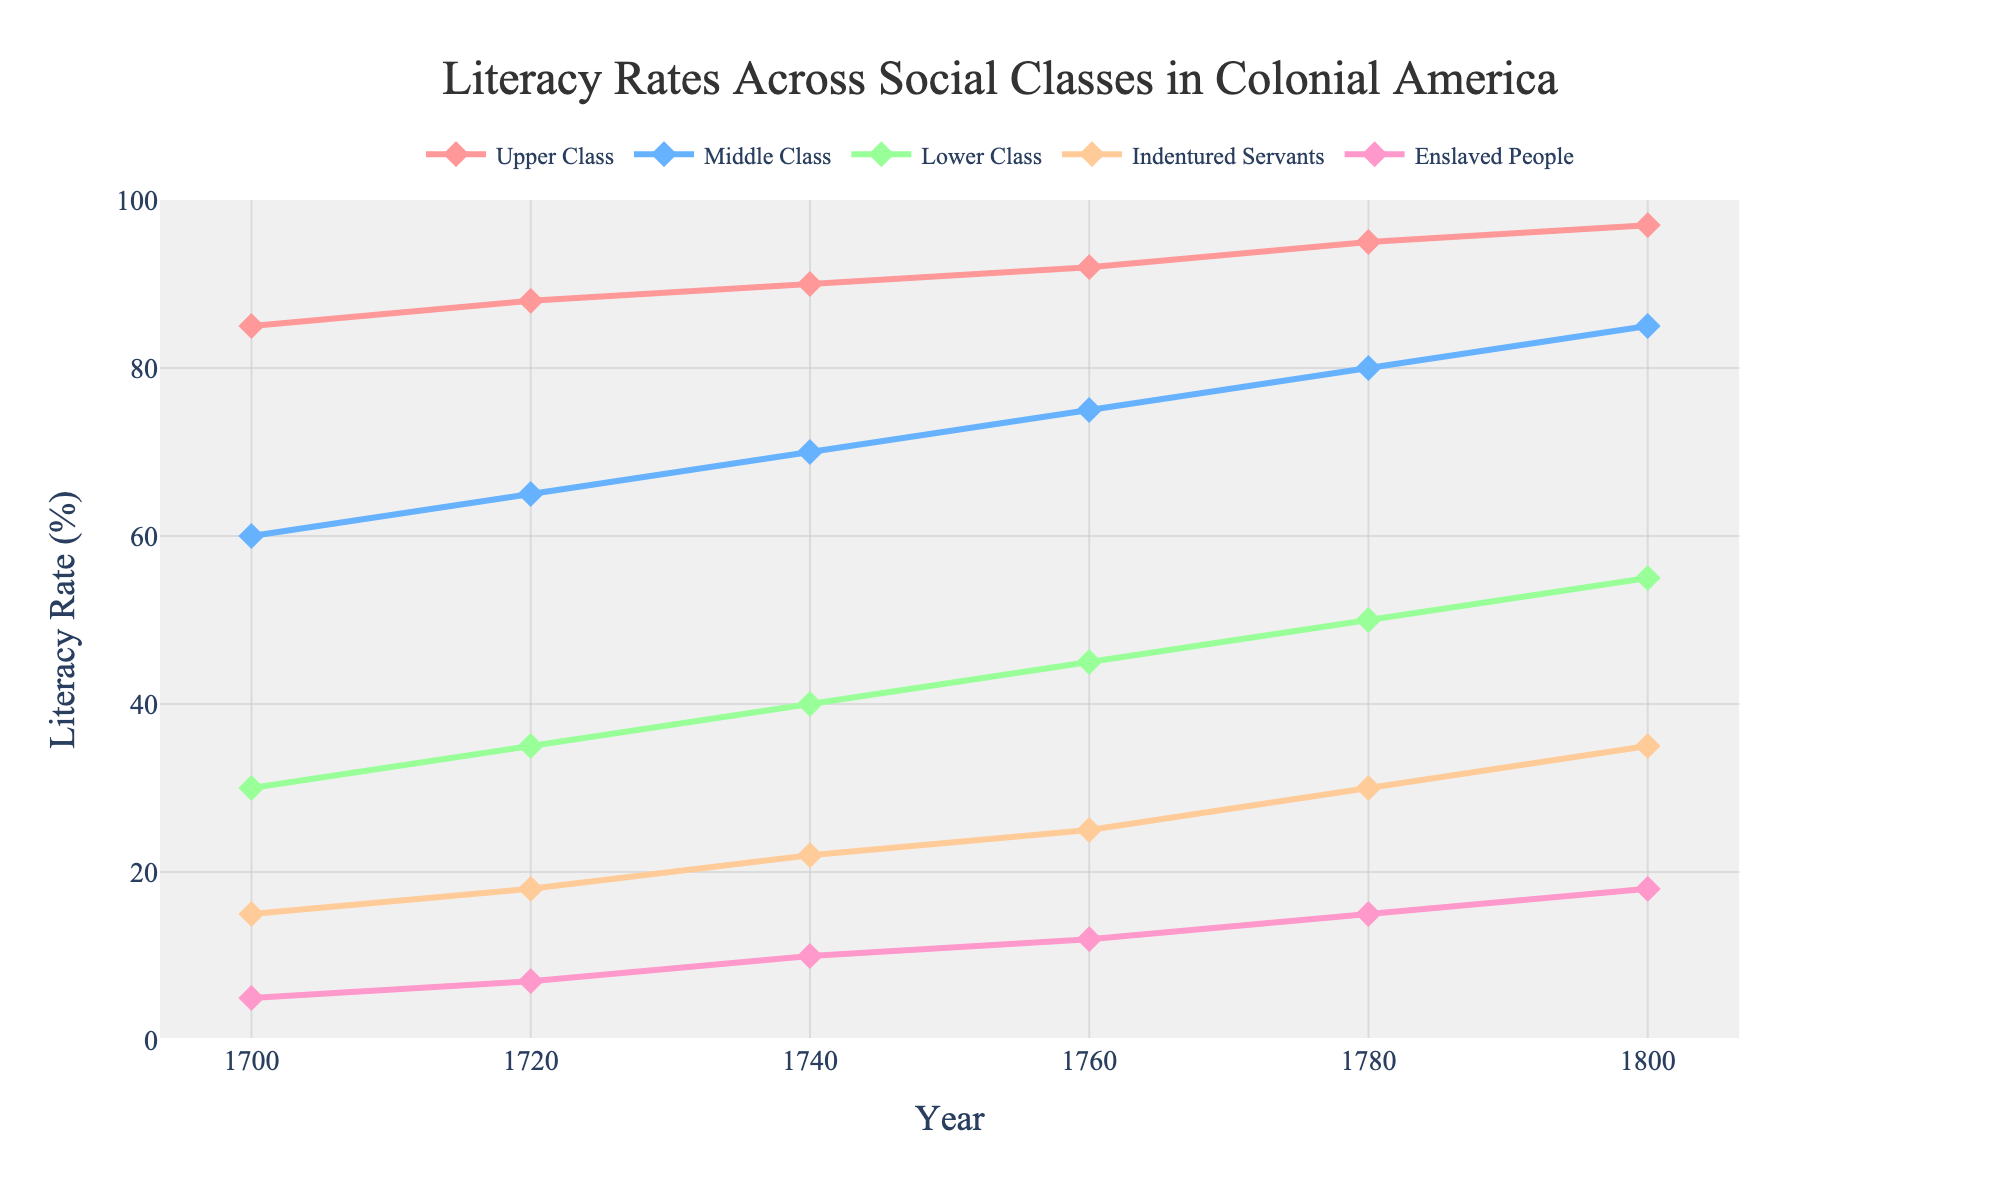Which social class had the highest literacy rate in 1760? In 1760, the line corresponding to the Upper Class in the figure is at the highest position compared to other social classes.
Answer: Upper Class How much did the literacy rate of Indentured Servants increase from 1700 to 1800? In 1700, the literacy rate for Indentured Servants was 15%, and it increased to 35% in 1800. The difference is 35% - 15% = 20%.
Answer: 20% Between 1720 and 1740, which social class showed the greatest increase in literacy rate? The Middle Class increased from 65% to 70%, which is a change of 5%. The Lower Class increased from 35% to 40%, also a change of 5%. Indentured Servants rose from 18% to 22%, a 4% change. Enslaved People saw an increase from 7% to 10%, a 3% change. The Upper Class increased from 88% to 90%, a 2% change. Therefore, the Middle and Lower Classes showed the greatest increase, both by 5%.
Answer: Middle Class and Lower Class What was the difference in literacy rate between the Upper Class and Enslaved People in 1780? In 1780, the Upper Class had a literacy rate of 95% and Enslaved People had a literacy rate of 15%. The difference is 95% - 15% = 80%.
Answer: 80% Which years had the same literacy rate for both Middle Class and Indentured Servants? By examining the lines representing the Middle Class and Indentured Servants, there is no year where both groups have the same literacy rate.
Answer: None What was the average literacy rate of the Lower Class throughout the time period shown? Calculate the average literacy rate by summing the rates for 1700, 1720, 1740, 1760, 1780, and 1800 and then dividing by the number of years. (30 + 35 + 40 + 45 + 50 + 55)/6 = 255/6 = 42.5%.
Answer: 42.5% During which decade did the literacy rate of Enslaved People show the most significant increase? Examining the increments: 1700-1720 = 2%, 1720-1740 = 3%, 1740-1760 = 2%, 1760-1780 = 3%, 1780-1800 = 3%. Therefore, the decade 1720-1740 shows the most significant increase.
Answer: 1720-1740 Out of the Middle Class, Lower Class, and Indentured Servants, which had the highest literacy rate in 1800? In 1800, the literacy rate of the Middle Class (85%) exceeded that of the Lower Class (55%) and Indentured Servants (35%).
Answer: Middle Class How did the literacy rate of Enslaved People in 1780 compare to the literacy rate of Lower Class in 1700? In 1780, the literacy rate of Enslaved People was 15%, while the Lower Class had a literacy rate of 30% in 1700. Therefore, the literacy rate of Enslaved People in 1780 was lower.
Answer: Lower If you sum the literacy rates of all social classes in 1740, what is the total? Add the literacy rates for all mentioned social classes in 1740: Upper Class 90% + Middle Class 70% + Lower Class 40% + Indentured Servants 22% + Enslaved People 10% = 90 + 70 + 40 + 22 + 10 = 232%.
Answer: 232% 